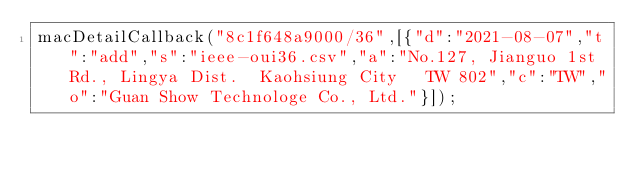<code> <loc_0><loc_0><loc_500><loc_500><_JavaScript_>macDetailCallback("8c1f648a9000/36",[{"d":"2021-08-07","t":"add","s":"ieee-oui36.csv","a":"No.127, Jianguo 1st Rd., Lingya Dist.  Kaohsiung City   TW 802","c":"TW","o":"Guan Show Technologe Co., Ltd."}]);
</code> 